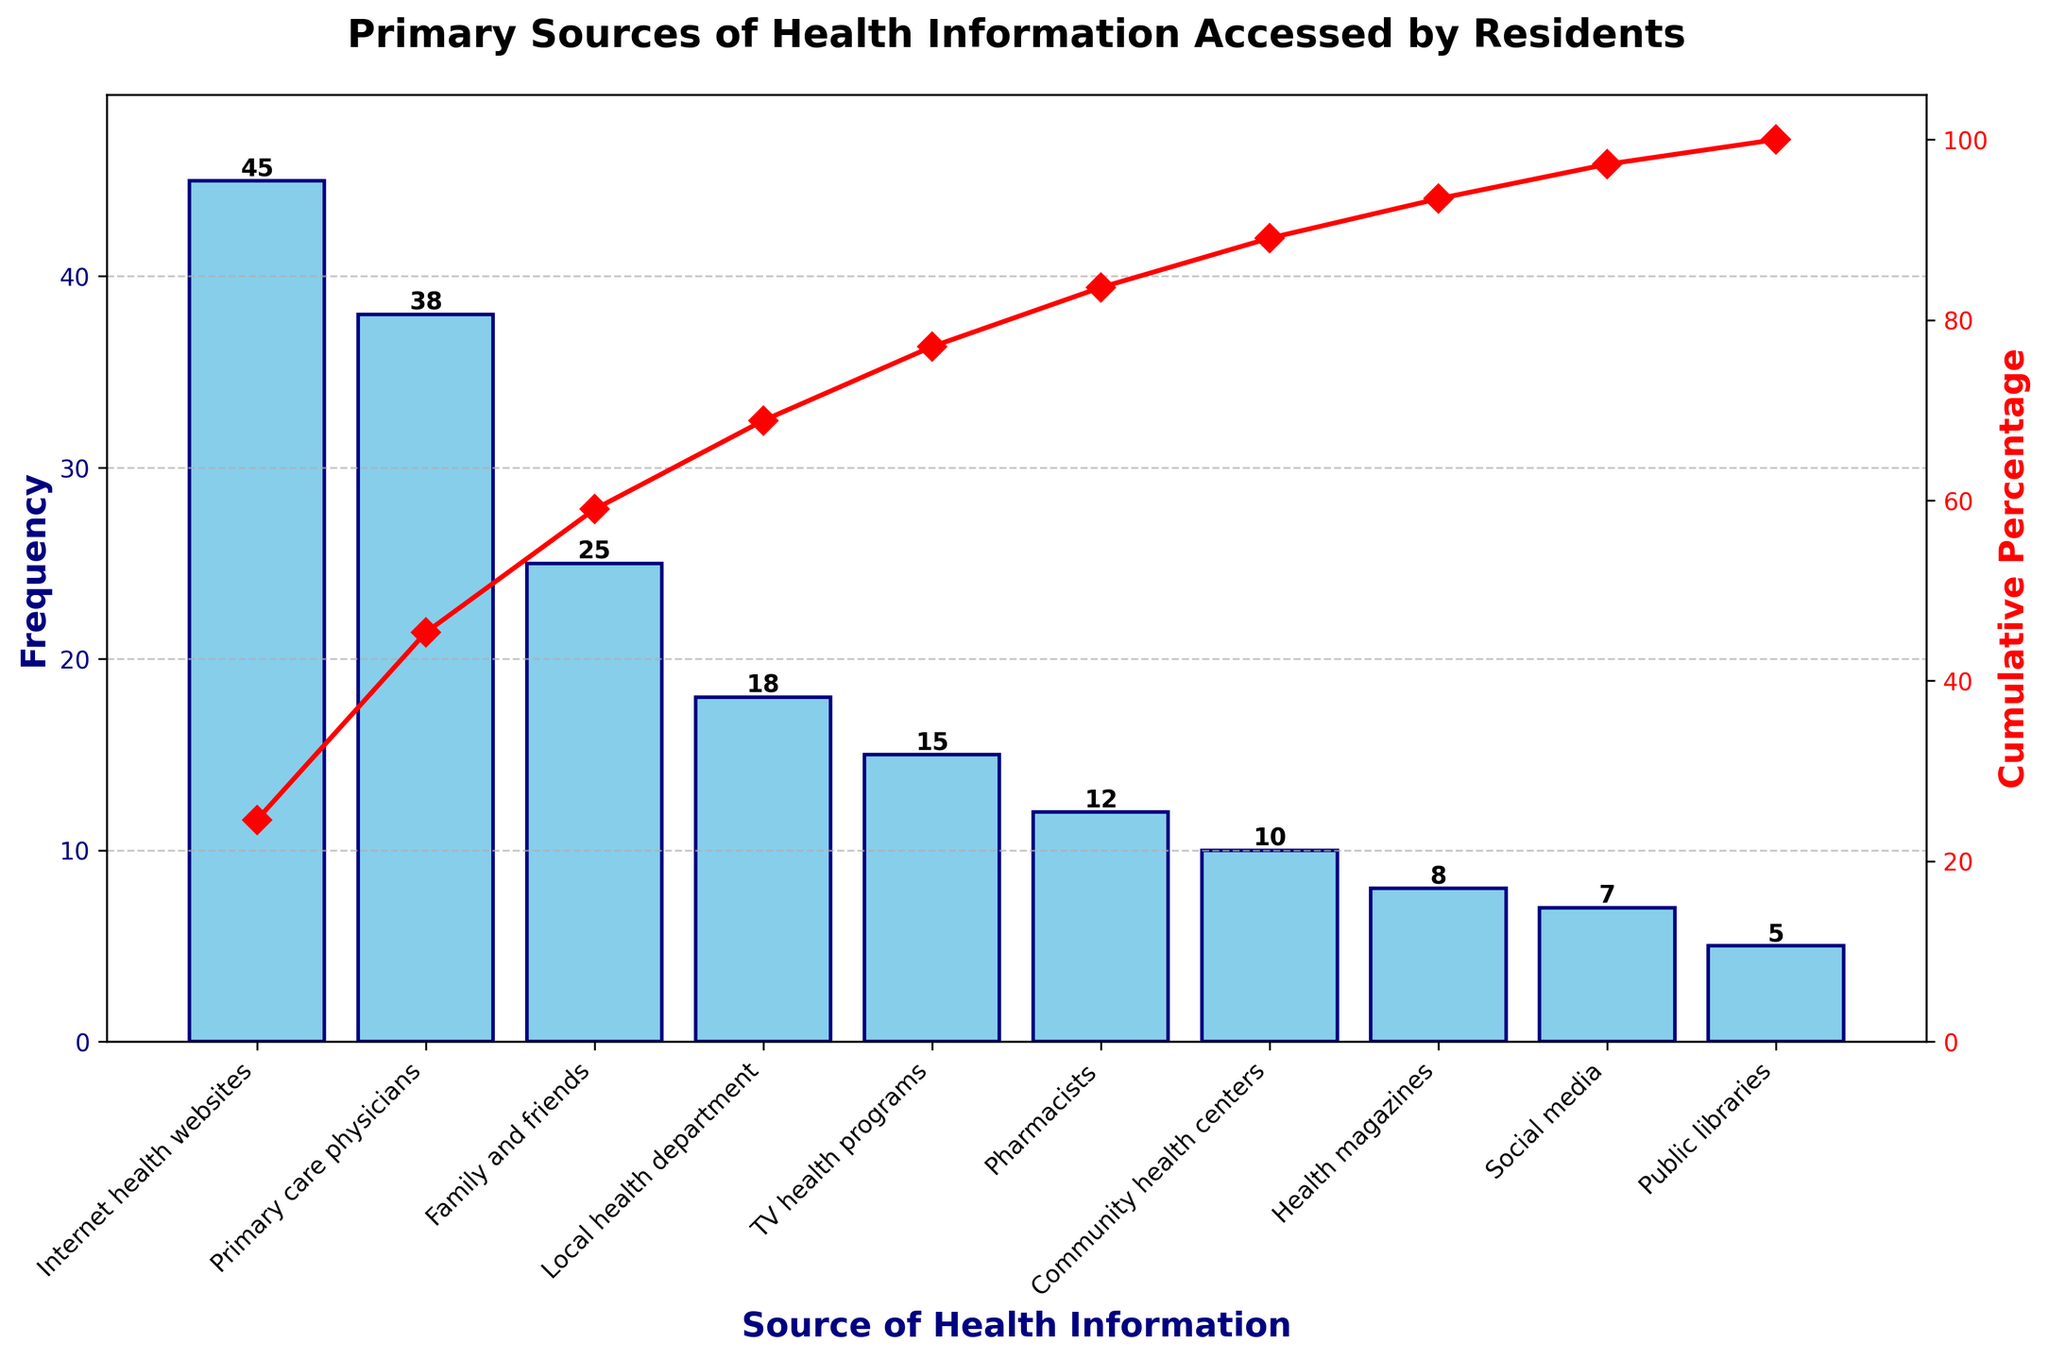What is the title of the figure? The title of the figure is usually at the top of the chart and describes what the chart is about. In this case, it reads "Primary Sources of Health Information Accessed by Residents".
Answer: "Primary Sources of Health Information Accessed by Residents" Which source has the highest frequency? The highest bar in the chart represents the source with the highest frequency. In this case, "Internet health websites" is the highest bar, indicating it has the highest frequency.
Answer: Internet health websites What is the frequency of Social Media as a source of health information? Look for the bar labeled "Social media". The number at the top of this bar indicates the frequency, which is 7.
Answer: 7 What is the cumulative percentage when reaching Pharmacists? Find the cumulative percentage line on the chart and observe its value at the point corresponding to Pharmacists. The cumulative percentage at this point is around 94%.
Answer: 94% How does the frequency of Primary care physicians compare with Family and friends? Compare the heights of the bars for "Primary care physicians" and "Family and friends". The bar for "Primary care physicians" is higher than that for "Family and friends", indicating a higher frequency. Specifically, "Primary care physicians" has a frequency of 38, while "Family and friends" has a frequency of 25.
Answer: Primary care physicians is higher What is the combined frequency of Local health department, TV health programs, and Pharmacists? Add the frequencies for "Local health department" (18), "TV health programs" (15), and "Pharmacists" (12). The combined frequency is 18 + 15 + 12 = 45.
Answer: 45 What is the percentage contribution of TV health programs to the total frequency? Calculate the percentage by dividing the frequency of "TV health programs" (15) by the total frequency (183) and then multiplying by 100. The total frequency is the sum of all bars. The calculation is (15 / 183) * 100 ≈ 8.20%.
Answer: 8.20% Which sources make up the top 80% of the cumulative percentage? Observe the cumulative percentage line and see which sources fall within the top 80%. The sources that cumulatively reach up to 80% are "Internet health websites", "Primary care physicians", "Family and friends", and "Local health department".
Answer: Internet health websites, Primary care physicians, Family and friends, Local health department How many different sources of health information are represented in the chart? Count the number of unique bars in the chart representing different sources of health information. There are 10 different sources.
Answer: 10 What is the frequency difference between the source with the highest and the source with the lowest frequency? Identify the highest frequency (45 for Internet health websites) and the lowest frequency (5 for Public libraries) and subtract the latter from the former (45 - 5 = 40).
Answer: 40 